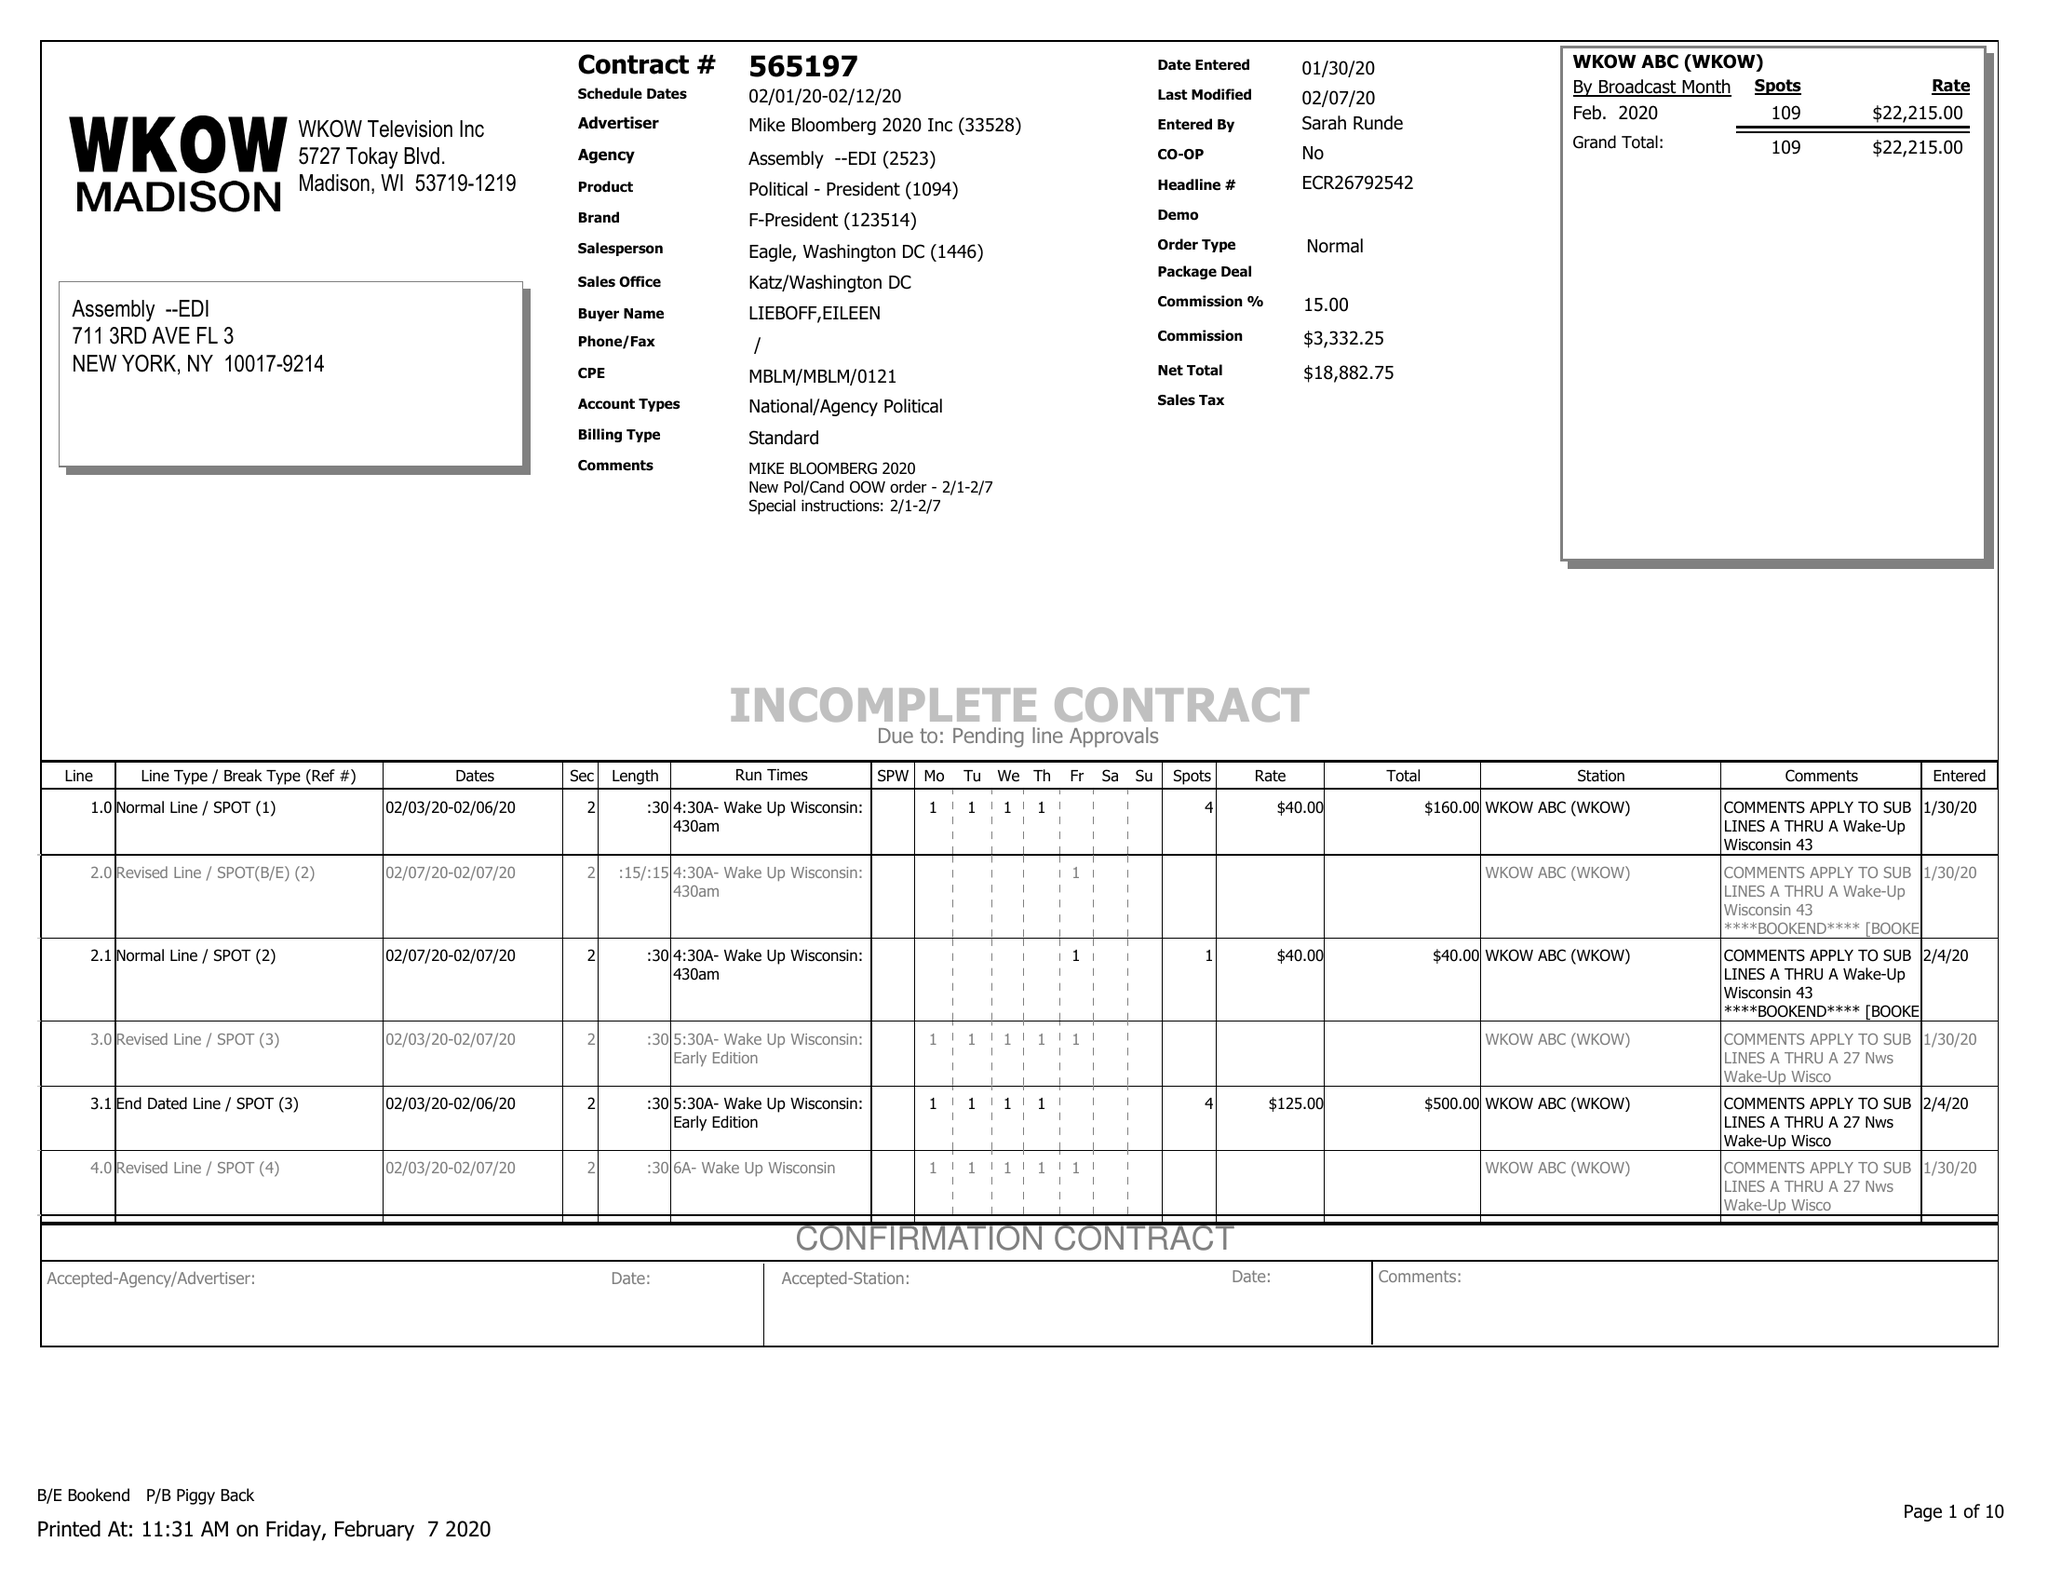What is the value for the gross_amount?
Answer the question using a single word or phrase. 22215.00 